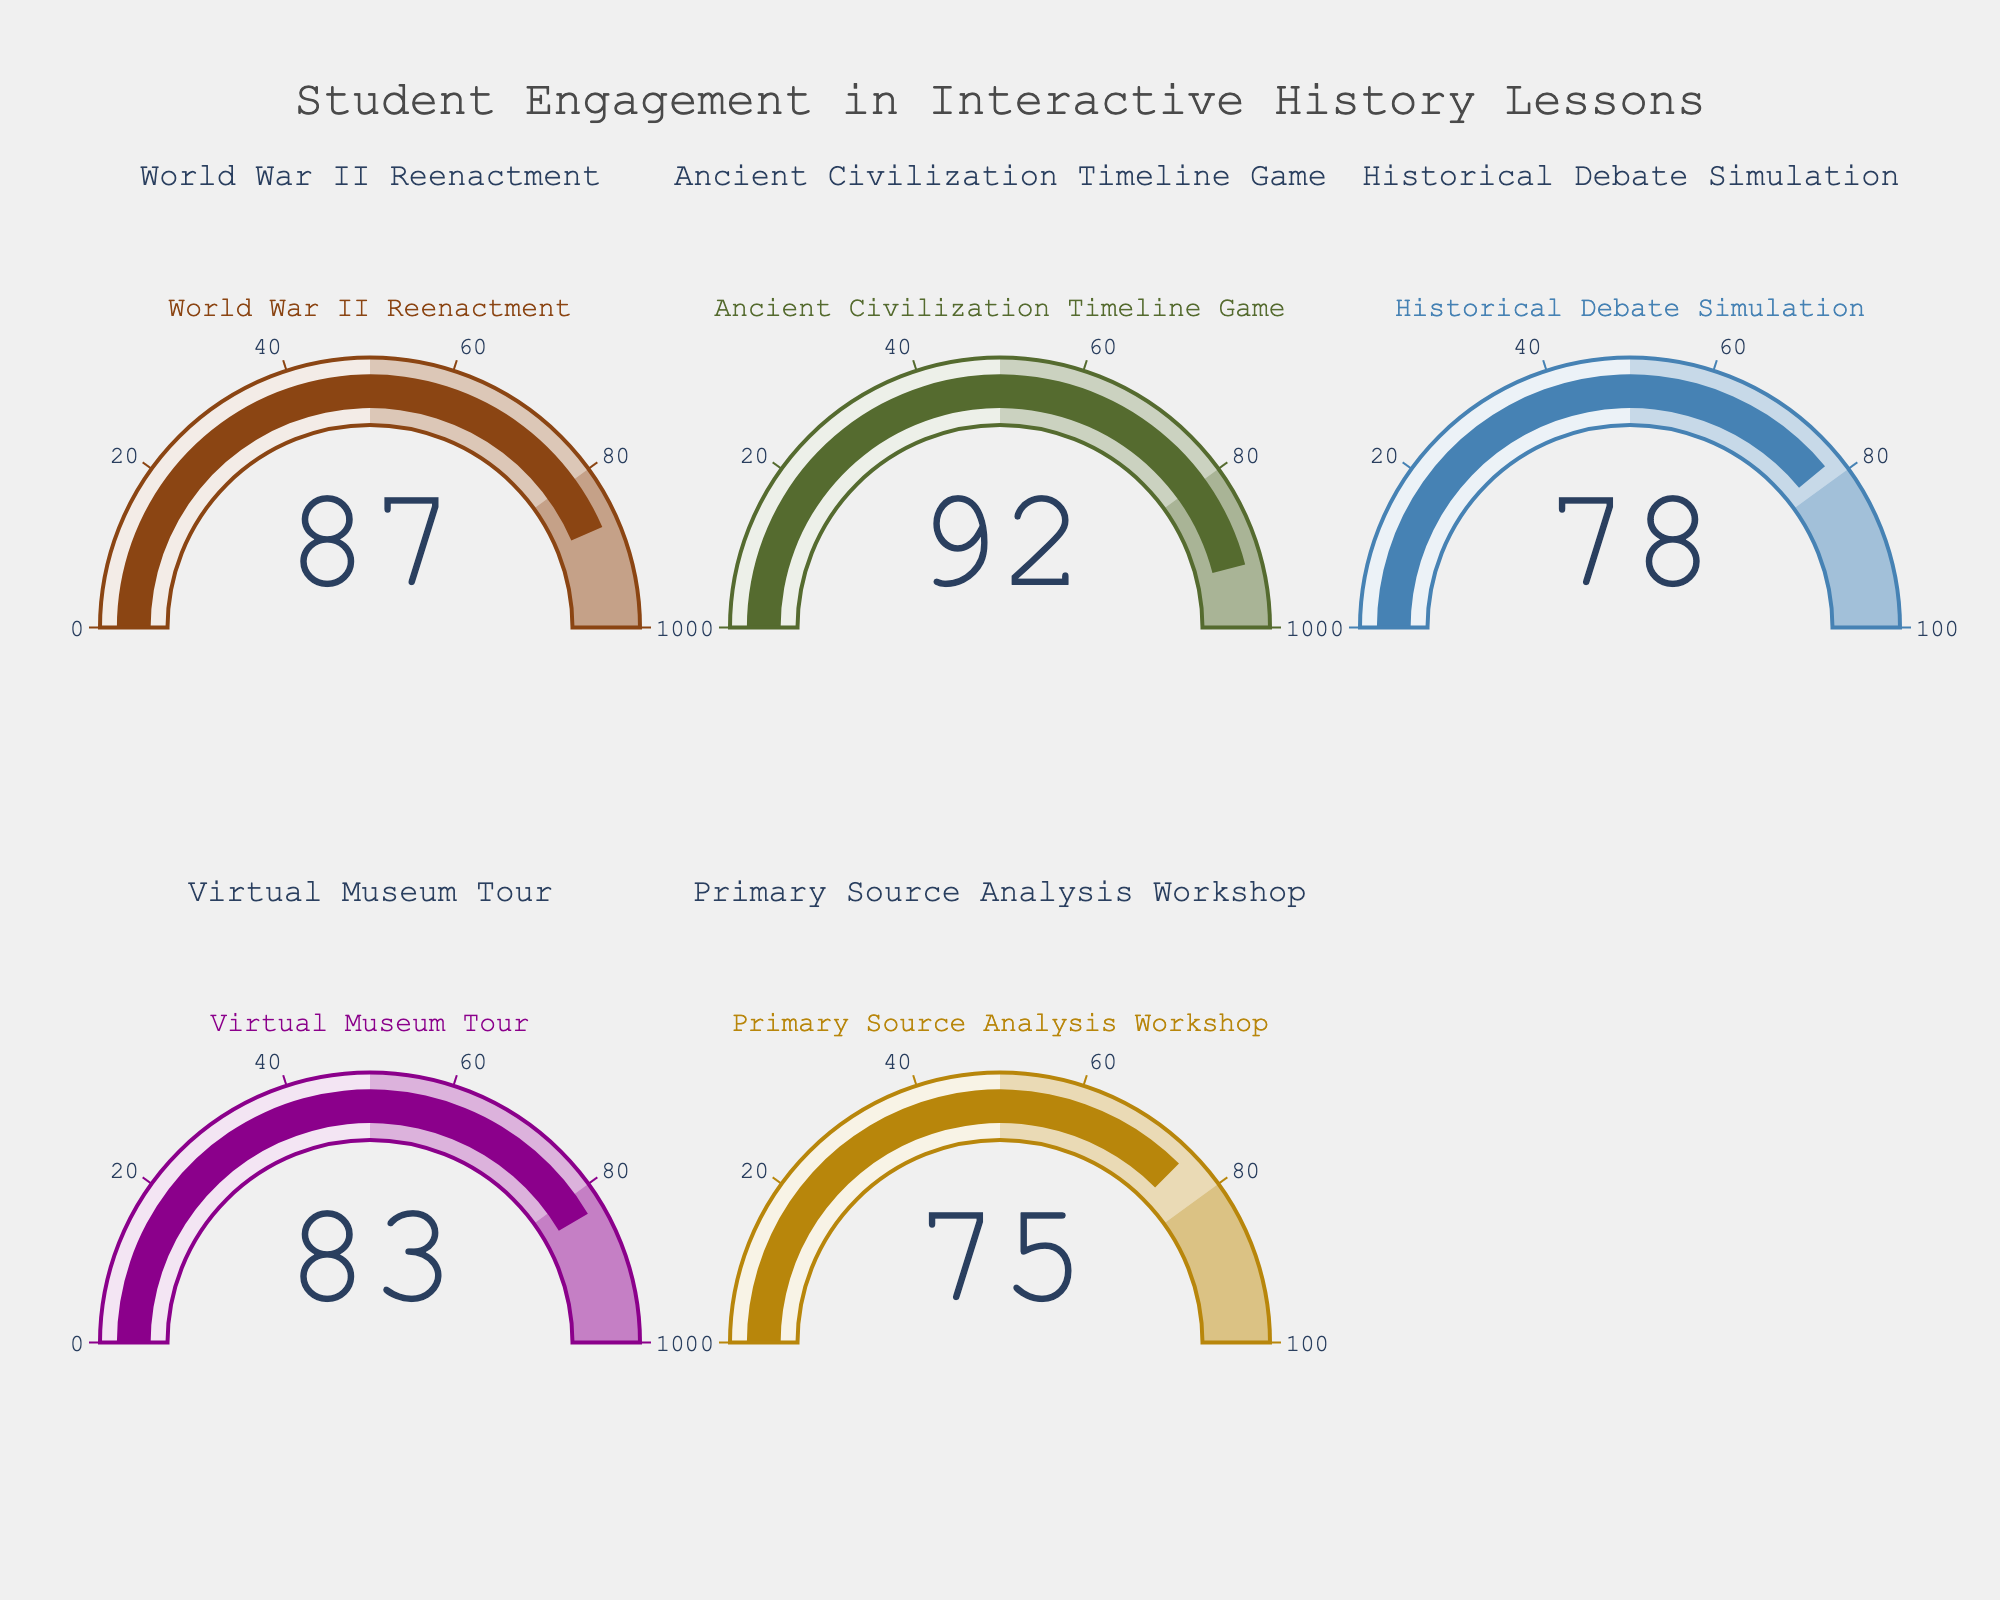What's the highest student engagement level indicated on the gauge chart? Look through all the gauges and identify the highest value, which is 92 for the Ancient Civilization Timeline Game.
Answer: 92 Which interactive history lesson had the lowest student engagement level? Compare the values on each gauge and identify the lowest one, which is the Primary Source Analysis Workshop with a value of 75.
Answer: Primary Source Analysis Workshop What's the average engagement level across all interactive history lessons? Add all the engagement levels (87+92+78+83+75) to get 415, then divide by the number of lessons, which is 5.
Answer: 83 How many interactive history lessons have an engagement level above 80? Identify all the lessons with engagement levels above 80 (87, 92, 83), which are 3 in total.
Answer: 3 Is the engagement level for the Historical Debate Simulation greater than for the Virtual Museum Tour? Compare the values of the Historical Debate Simulation (78) and the Virtual Museum Tour (83). The engagement level for the Virtual Museum Tour is higher.
Answer: No What's the difference in engagement levels between the World War II Reenactment and the Primary Source Analysis Workshop? Subtract the engagement level of the Primary Source Analysis Workshop (75) from the World War II Reenactment (87).
Answer: 12 Which event showed a student engagement level closest to 80? Look for the gauge value closest to 80. The Historical Debate Simulation has a value of 78.
Answer: Historical Debate Simulation What percentage difference is there between the highest and lowest levels of student engagement? Calculate the difference between the highest (92) and the lowest (75), then divide by the lowest (75) and multiply by 100. ((92-75)/75) * 100 = 22.67%.
Answer: 22.67% Are there any interactive lessons with an equal engagement level? Observe the engagement levels on each gauge and see if any values are identical. They are all unique.
Answer: No 